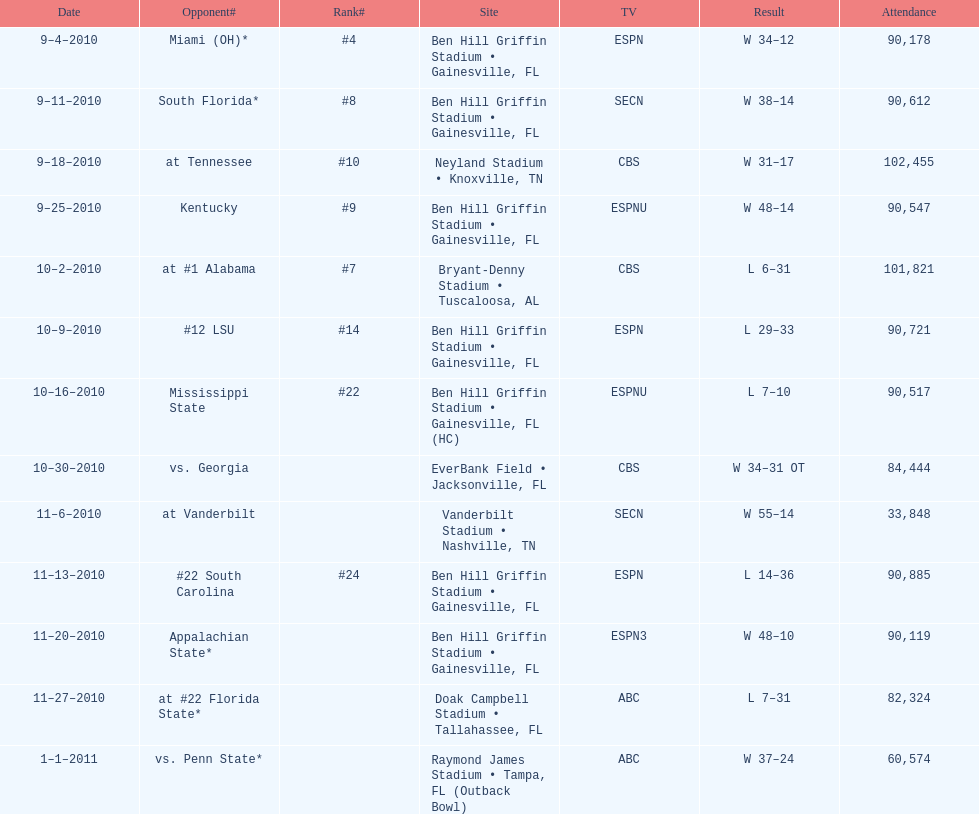How many games were played during the 2010-2011 season? 13. 